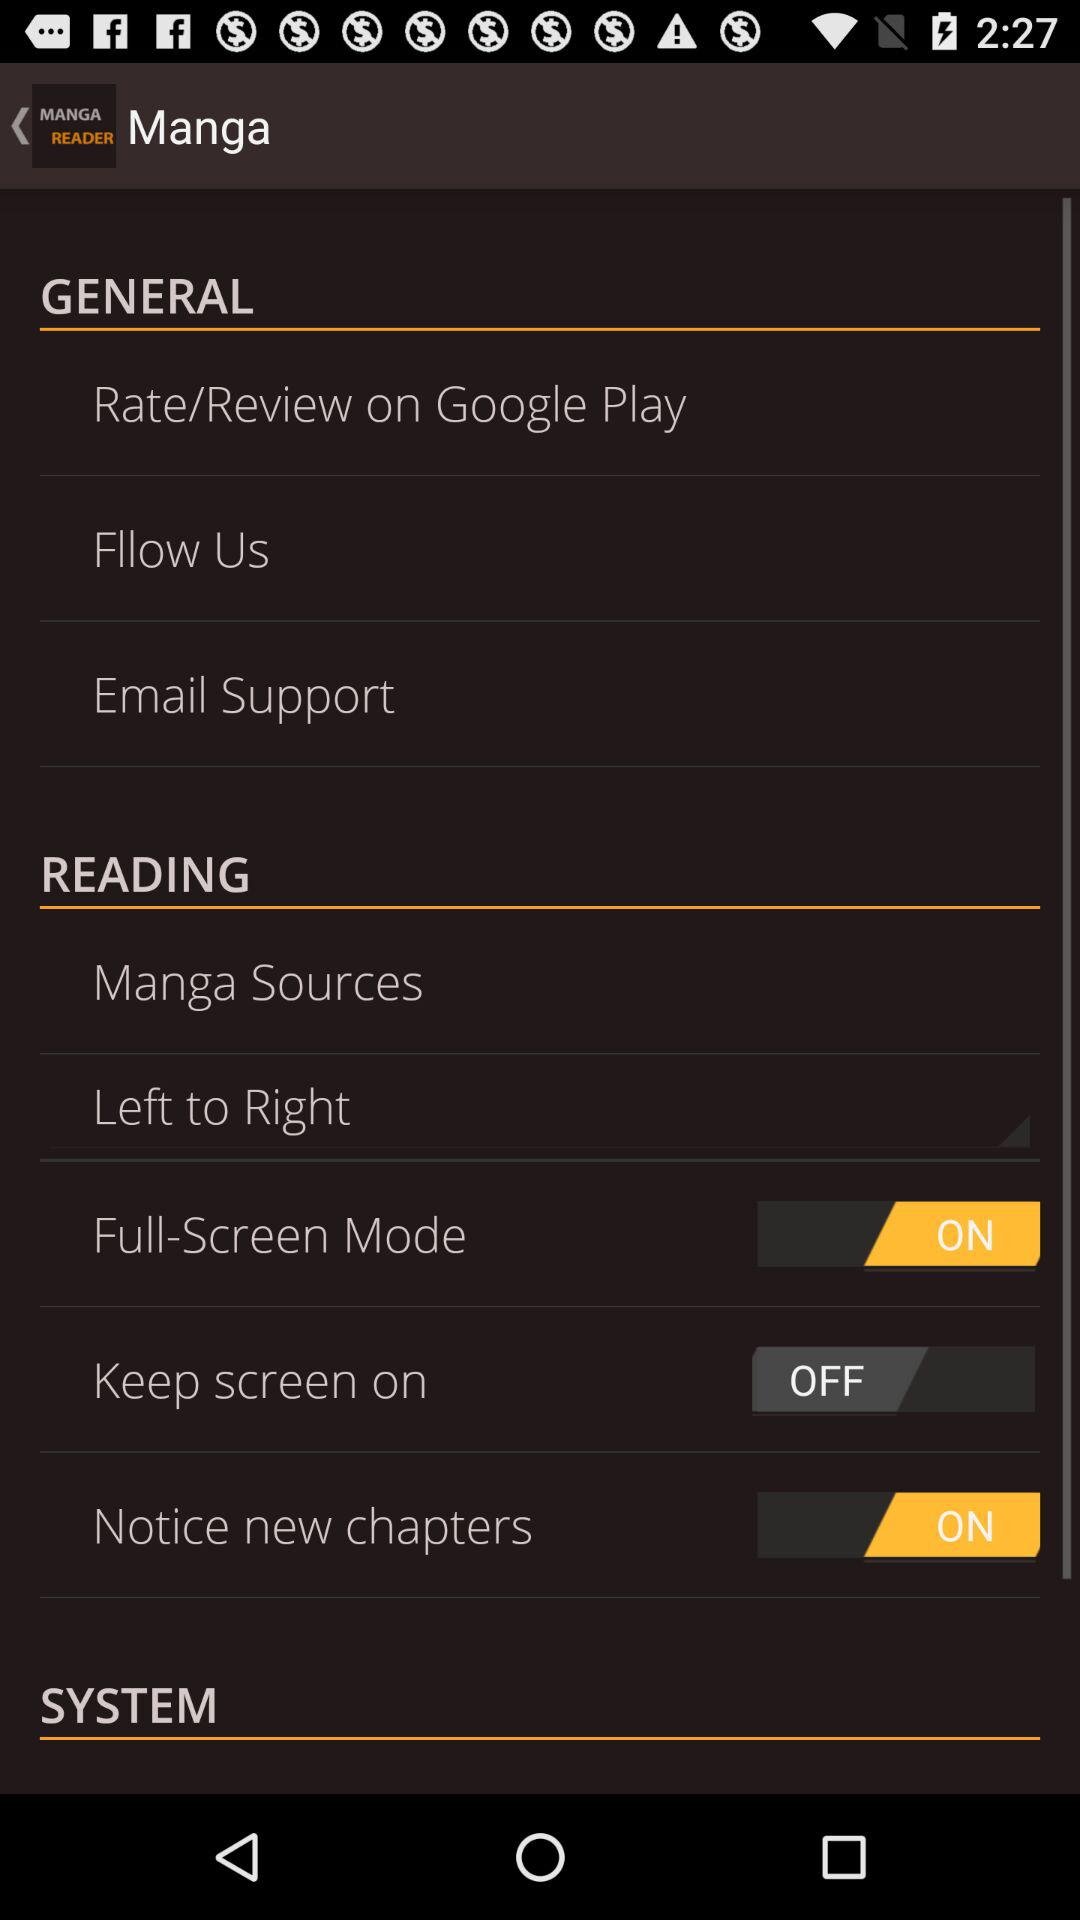How many items are in the General section?
Answer the question using a single word or phrase. 3 